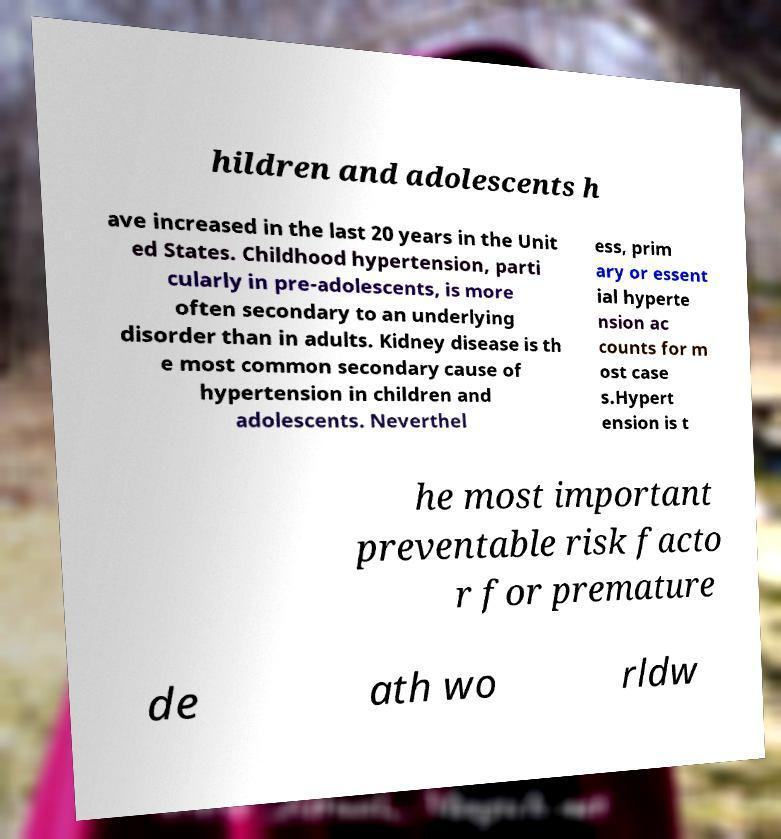Could you extract and type out the text from this image? hildren and adolescents h ave increased in the last 20 years in the Unit ed States. Childhood hypertension, parti cularly in pre-adolescents, is more often secondary to an underlying disorder than in adults. Kidney disease is th e most common secondary cause of hypertension in children and adolescents. Neverthel ess, prim ary or essent ial hyperte nsion ac counts for m ost case s.Hypert ension is t he most important preventable risk facto r for premature de ath wo rldw 